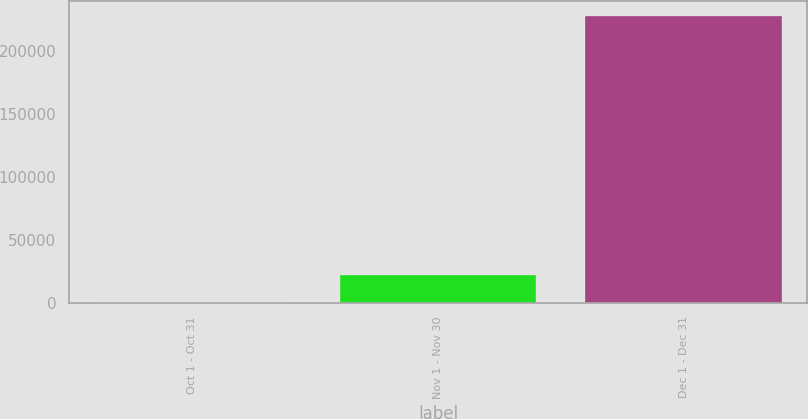Convert chart to OTSL. <chart><loc_0><loc_0><loc_500><loc_500><bar_chart><fcel>Oct 1 - Oct 31<fcel>Nov 1 - Nov 30<fcel>Dec 1 - Dec 31<nl><fcel>0.17<fcel>22800.2<fcel>228000<nl></chart> 